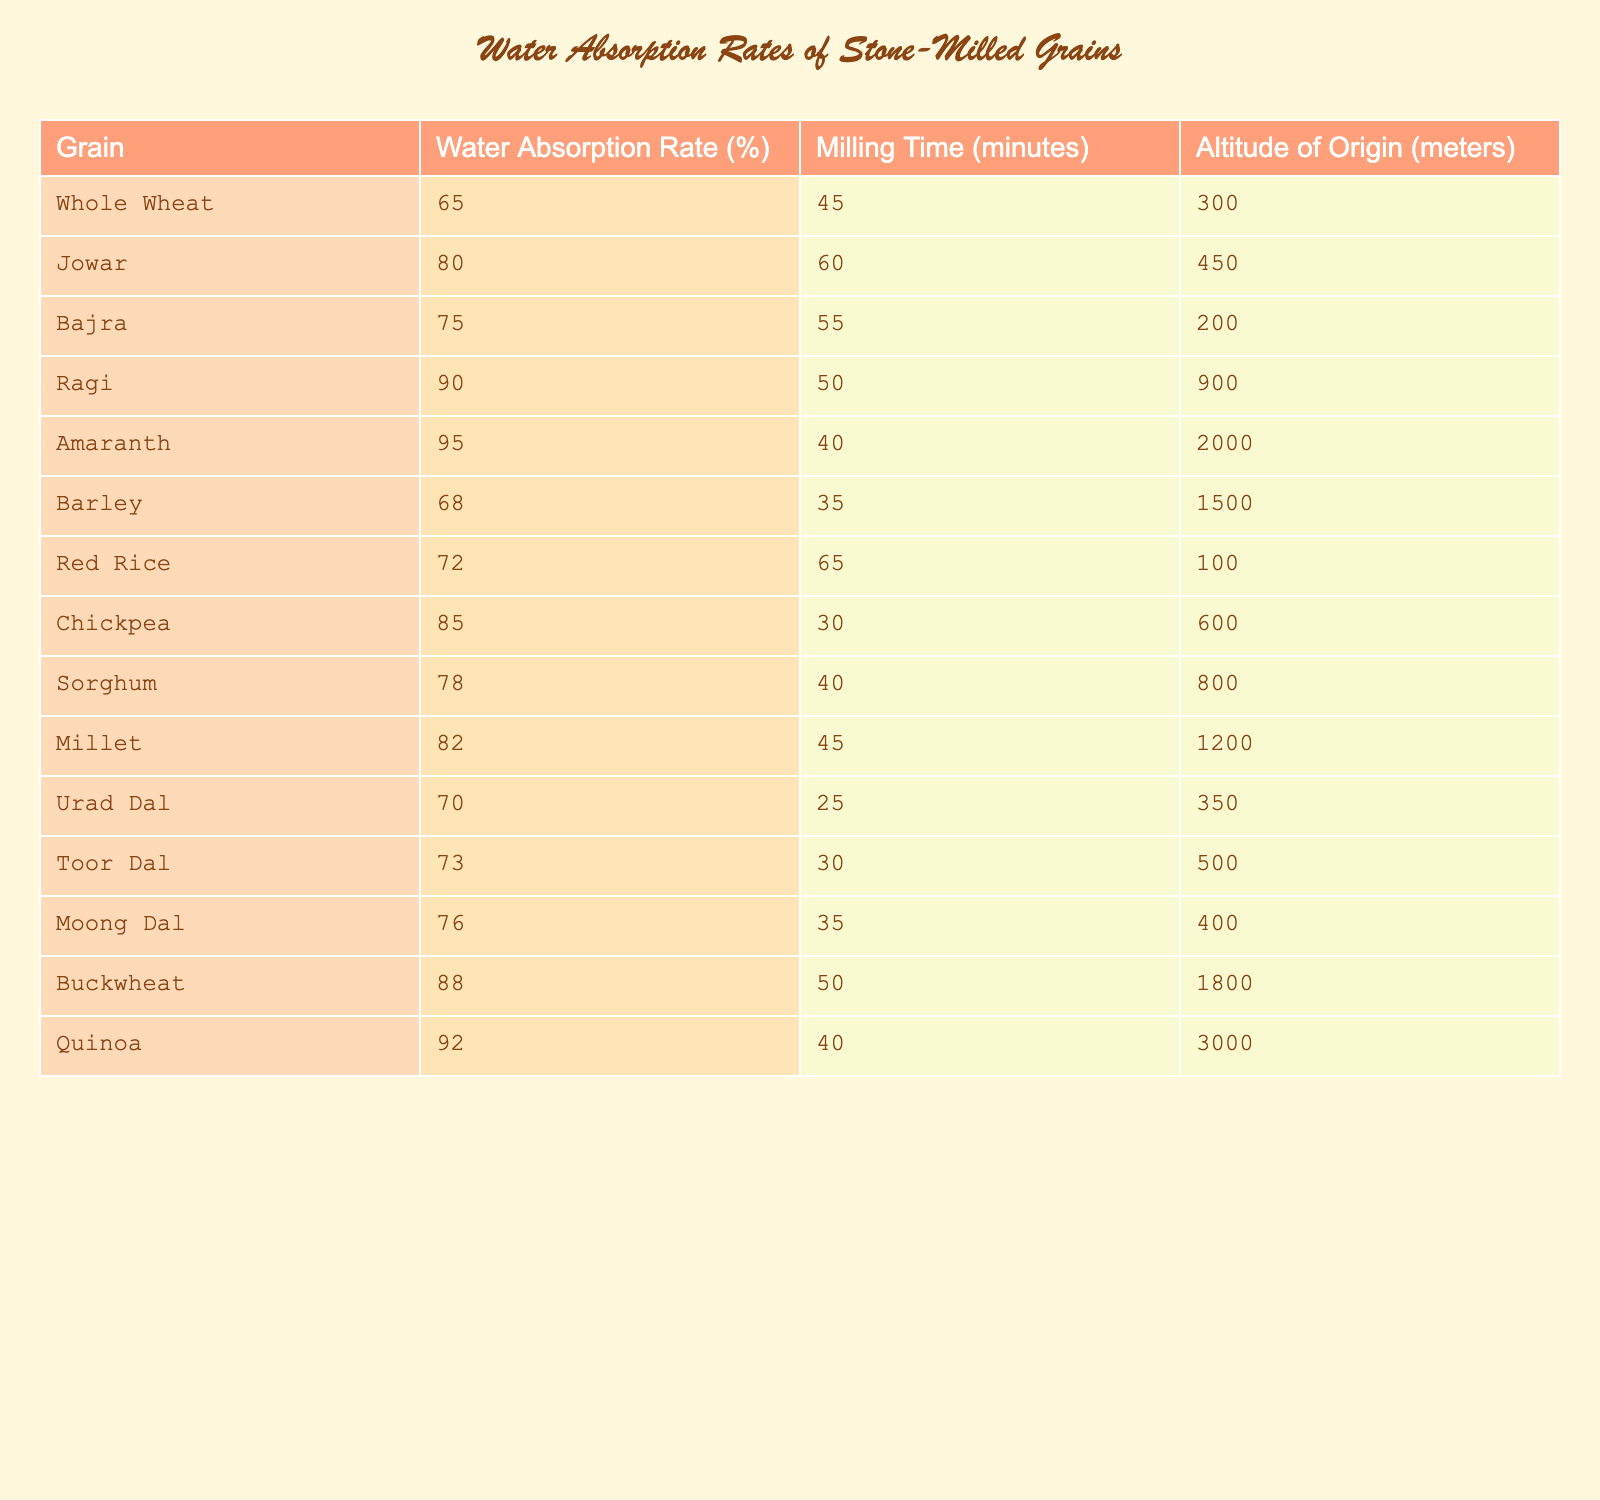What is the water absorption rate of Ragi? The table lists the water absorption rate of Ragi as 90%.
Answer: 90% Which grain has the highest water absorption rate? Amaranth has the highest water absorption rate at 95%.
Answer: 95% What is the average water absorption rate of Chickpea and Toor Dal? The water absorption rate of Chickpea is 85% and Toor Dal is 73%. To find the average, we add these rates: 85 + 73 = 158, then divide by 2: 158 / 2 = 79.
Answer: 79% Is the water absorption rate of Whole Wheat greater than 70%? Whole Wheat has a water absorption rate of 65%, which is not greater than 70%.
Answer: No What is the difference in water absorption rates between Amaranth and Barley? Amaranth has a water absorption rate of 95%, while Barley has 68%. The difference is calculated as 95 - 68 = 27%.
Answer: 27% Which grain requires the longest milling time? The table shows that Jowar requires the longest milling time of 60 minutes.
Answer: 60 minutes Identify the grain with the least water absorption rate. The water absorption rate for Whole Wheat is the lowest at 65%.
Answer: 65% What is the combined water absorption rate of Bajra and Sorghum? Bajra has a water absorption rate of 75% and Sorghum has 78%. The combined rate is calculated by adding them: 75 + 78 = 153%.
Answer: 153% Does Urad Dal have a higher or lower water absorption rate compared to Quinoa? Urad Dal has a rate of 70%, while Quinoa has a higher rate of 92%. Thus, Urad Dal has a lower water absorption rate.
Answer: Lower Which grain from the table comes from the highest altitude? Amaranth comes from the highest altitude of 2000 meters.
Answer: 2000 meters 